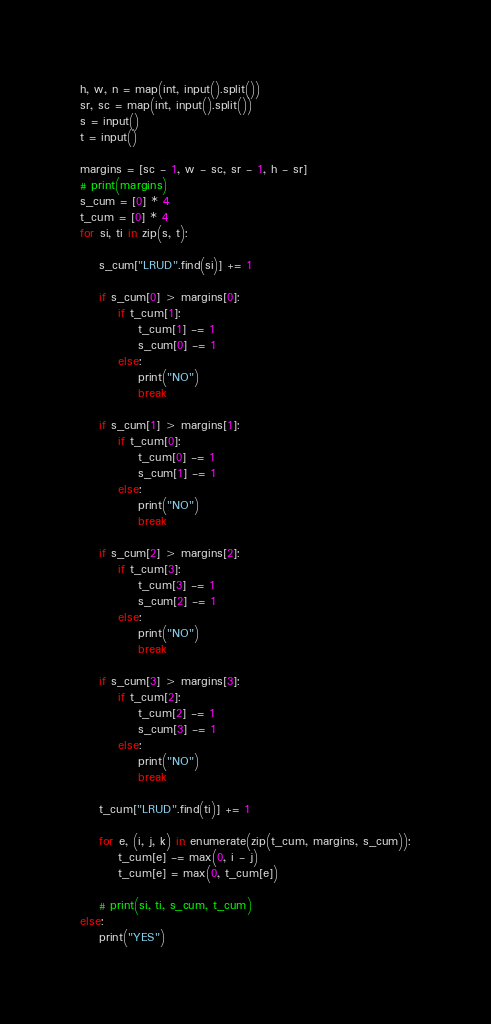<code> <loc_0><loc_0><loc_500><loc_500><_Python_>h, w, n = map(int, input().split())
sr, sc = map(int, input().split())
s = input()
t = input()

margins = [sc - 1, w - sc, sr - 1, h - sr]
# print(margins)
s_cum = [0] * 4
t_cum = [0] * 4
for si, ti in zip(s, t):

    s_cum["LRUD".find(si)] += 1

    if s_cum[0] > margins[0]:
        if t_cum[1]:
            t_cum[1] -= 1
            s_cum[0] -= 1
        else:
            print("NO")
            break

    if s_cum[1] > margins[1]:
        if t_cum[0]:
            t_cum[0] -= 1
            s_cum[1] -= 1
        else:
            print("NO")
            break

    if s_cum[2] > margins[2]:
        if t_cum[3]:
            t_cum[3] -= 1
            s_cum[2] -= 1
        else:
            print("NO")
            break

    if s_cum[3] > margins[3]:
        if t_cum[2]:
            t_cum[2] -= 1
            s_cum[3] -= 1
        else:
            print("NO")
            break

    t_cum["LRUD".find(ti)] += 1

    for e, (i, j, k) in enumerate(zip(t_cum, margins, s_cum)):
        t_cum[e] -= max(0, i - j)
        t_cum[e] = max(0, t_cum[e])

    # print(si, ti, s_cum, t_cum)
else:
    print("YES")

</code> 